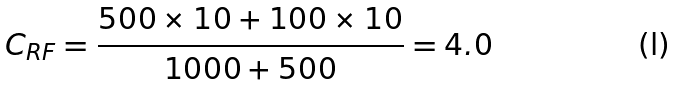<formula> <loc_0><loc_0><loc_500><loc_500>C _ { R F } = \frac { 5 0 0 \times 1 0 + 1 0 0 \times 1 0 } { 1 0 0 0 + 5 0 0 } = 4 . 0</formula> 